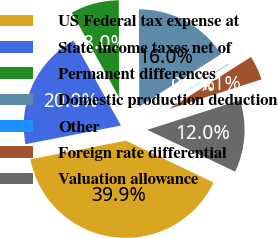<chart> <loc_0><loc_0><loc_500><loc_500><pie_chart><fcel>US Federal tax expense at<fcel>State income taxes net of<fcel>Permanent differences<fcel>Domestic production deduction<fcel>Other<fcel>Foreign rate differential<fcel>Valuation allowance<nl><fcel>39.86%<fcel>19.97%<fcel>8.04%<fcel>15.99%<fcel>0.08%<fcel>4.06%<fcel>12.01%<nl></chart> 